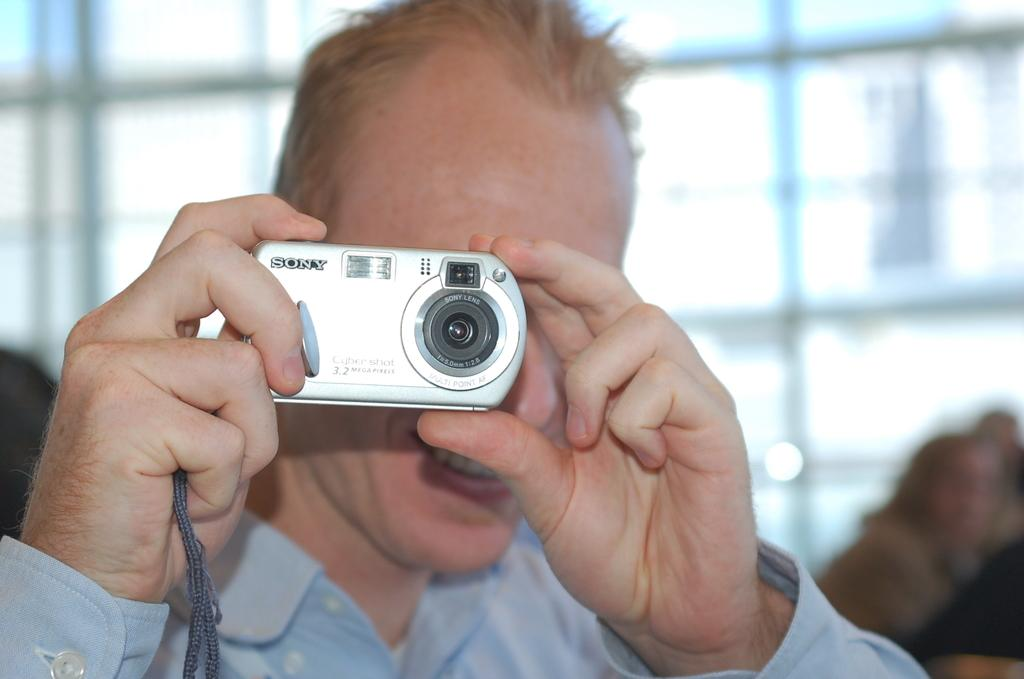What is the main subject of the image? The main subject of the image is a man. What is the man holding in the image? The man is holding a camera with his hands. What type of marble is the man using to give advice in the image? There is no marble or advice-giving activity present in the image; the man is simply holding a camera. 